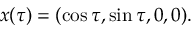<formula> <loc_0><loc_0><loc_500><loc_500>x ( \tau ) = ( \cos \tau , \sin \tau , 0 , 0 ) .</formula> 